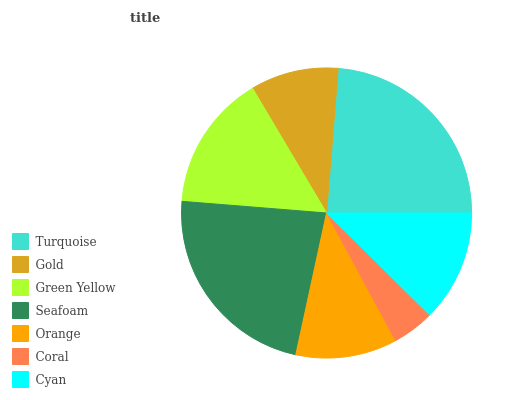Is Coral the minimum?
Answer yes or no. Yes. Is Turquoise the maximum?
Answer yes or no. Yes. Is Gold the minimum?
Answer yes or no. No. Is Gold the maximum?
Answer yes or no. No. Is Turquoise greater than Gold?
Answer yes or no. Yes. Is Gold less than Turquoise?
Answer yes or no. Yes. Is Gold greater than Turquoise?
Answer yes or no. No. Is Turquoise less than Gold?
Answer yes or no. No. Is Cyan the high median?
Answer yes or no. Yes. Is Cyan the low median?
Answer yes or no. Yes. Is Seafoam the high median?
Answer yes or no. No. Is Turquoise the low median?
Answer yes or no. No. 